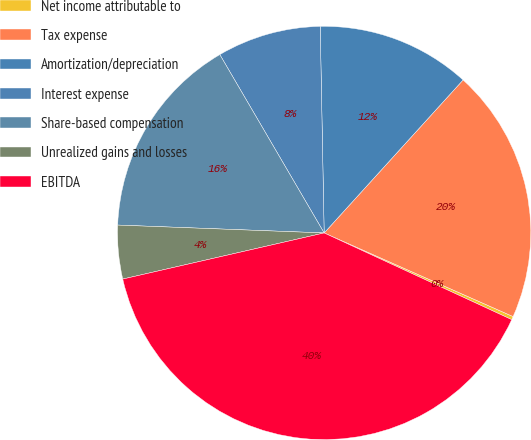Convert chart to OTSL. <chart><loc_0><loc_0><loc_500><loc_500><pie_chart><fcel>Net income attributable to<fcel>Tax expense<fcel>Amortization/depreciation<fcel>Interest expense<fcel>Share-based compensation<fcel>Unrealized gains and losses<fcel>EBITDA<nl><fcel>0.26%<fcel>19.9%<fcel>12.04%<fcel>8.12%<fcel>15.97%<fcel>4.19%<fcel>39.53%<nl></chart> 